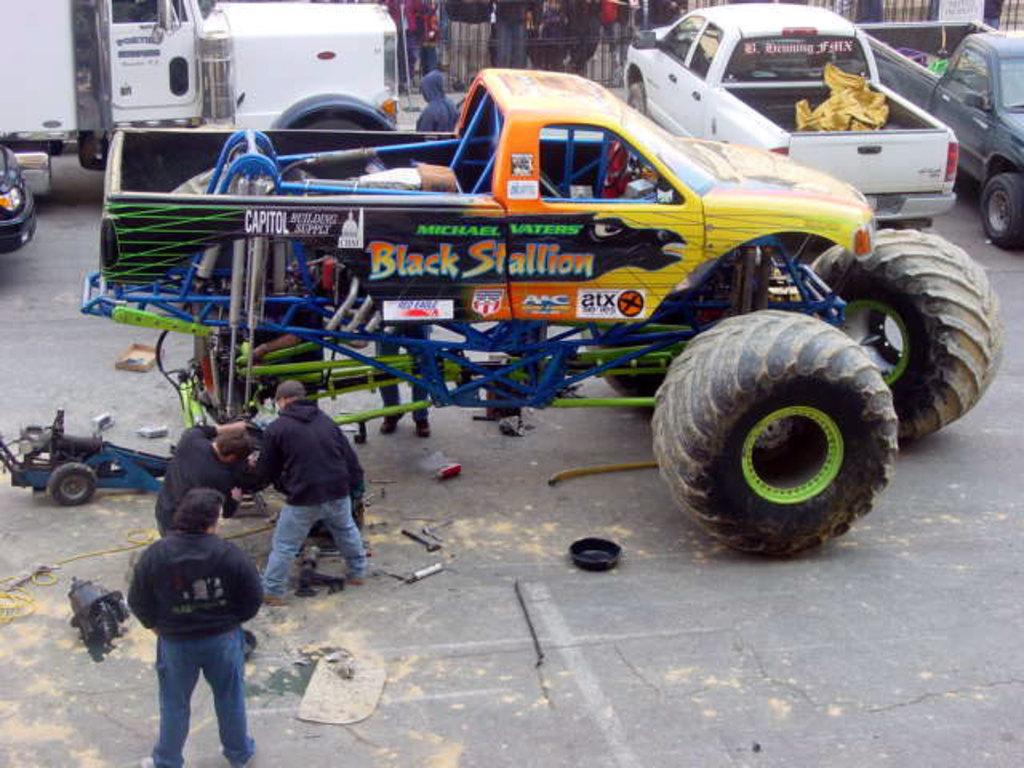<image>
Summarize the visual content of the image. Men work on a pick up truck with huge oversized tires that is named the Black Stallion. 